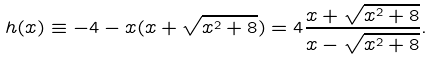Convert formula to latex. <formula><loc_0><loc_0><loc_500><loc_500>h ( x ) \equiv - 4 - x ( x + \sqrt { x ^ { 2 } + 8 } ) = 4 \frac { x + \sqrt { x ^ { 2 } + 8 } } { x - \sqrt { x ^ { 2 } + 8 } } .</formula> 